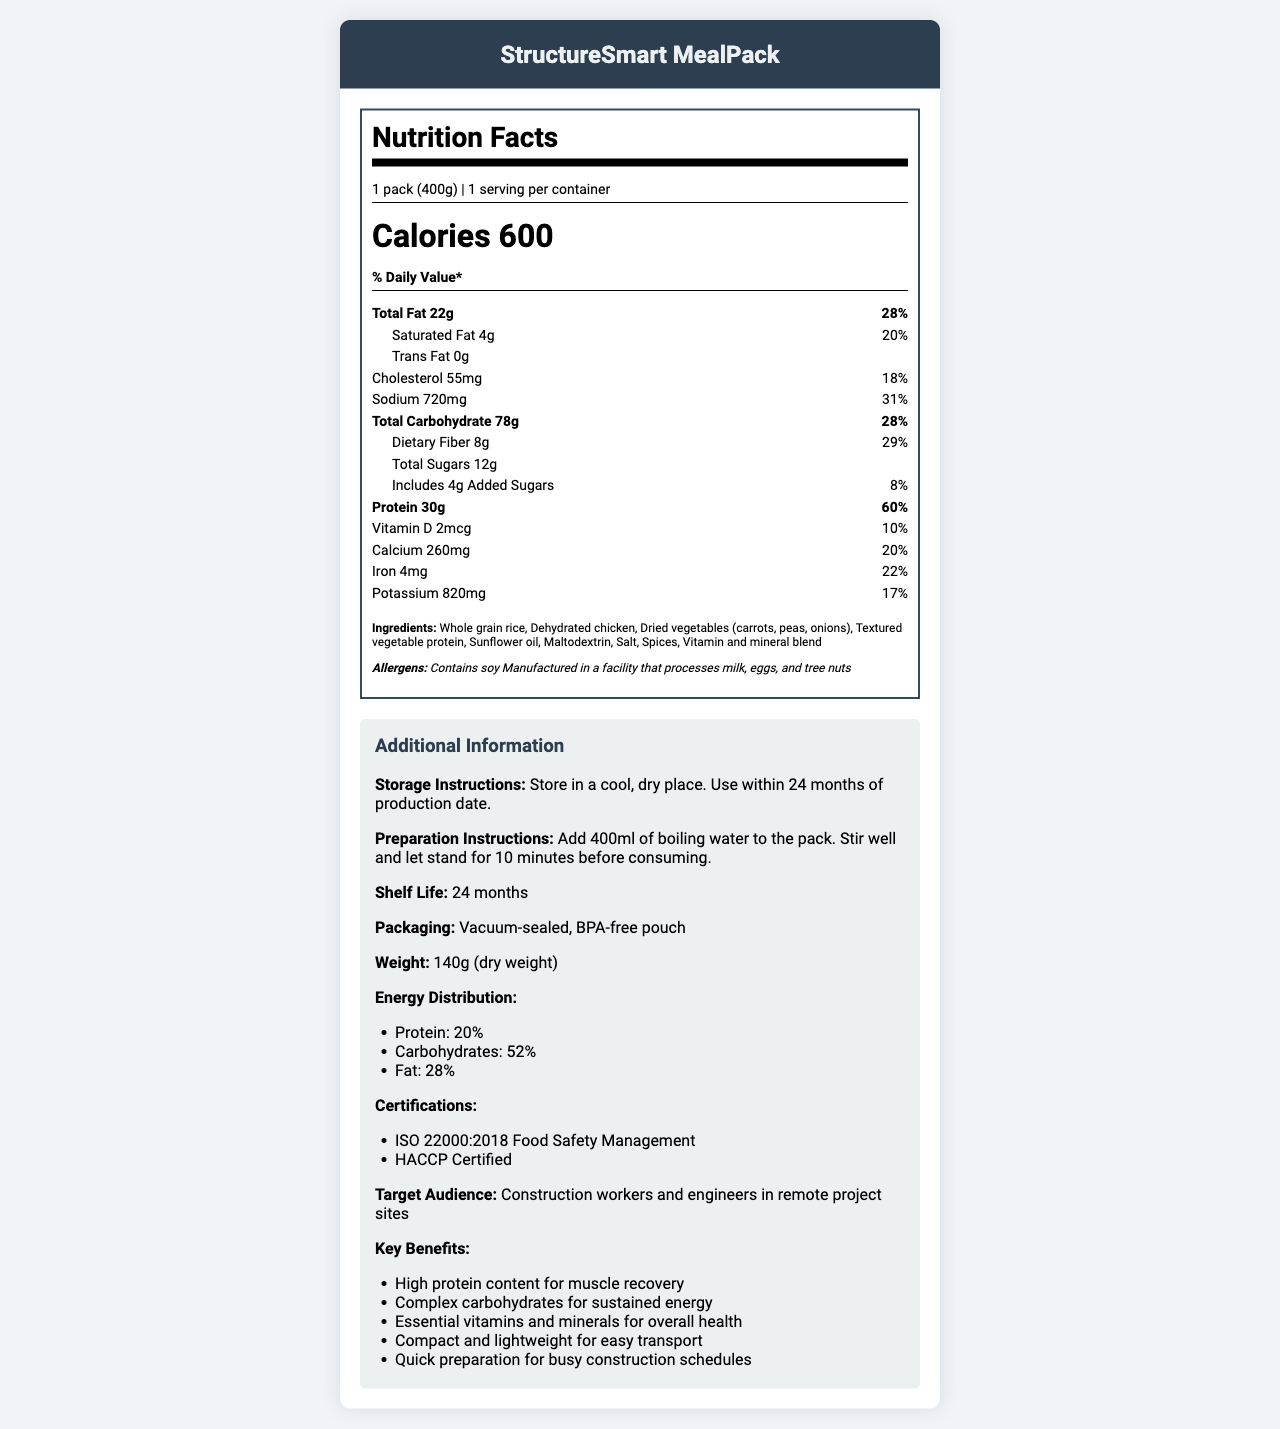what is the serving size for StructureSmart MealPack? The document clearly states that the serving size is "1 pack (400g)" under the serving information section.
Answer: 1 pack (400g) how many calories does one pack contain? The label indicates that there are 600 calories per serving, and since there is only one serving per container, one pack contains 600 calories.
Answer: 600 what is the total fat content for one serving, and what percentage of the daily value does it represent? The document lists the total fat as 22g, which is 28% of the daily value.
Answer: 22g, 28% how much dietary fiber is in one pack, and what's its daily value percentage? The document specifies that one pack contains 8g of dietary fiber, which is 29% of the daily value.
Answer: 8g, 29% what are the three primary ingredients of the StructureSmart MealPack? The primary ingredients listed first are "Whole grain rice", "Dehydrated chicken", and "Dried vegetables (carrots, peas, onions)".
Answer: Whole grain rice, Dehydrated chicken, Dried vegetables (carrots, peas, onions) what is the daily value percentage of protein provided by the StructureSmart MealPack? The document details that the protein content is 30g, which accounts for 60% of the daily value.
Answer: 60% what are the key benefits of the StructureSmart MealPack? The additional information section lists these key benefits.
Answer: High protein content for muscle recovery, Complex carbohydrates for sustained energy, Essential vitamins and minerals for overall health, Compact and lightweight for easy transport, Quick preparation for busy construction schedules does the StructureSmart MealPack contain any allergens? The document specifies that the product contains soy and is manufactured in a facility that processes milk, eggs, and tree nuts.
Answer: Yes what is the weight of StructureSmart MealPack in its dry form? Under additional information, the document states that the weight of the dry pack is 140g.
Answer: 140g who is the target audience for the StructureSmart MealPack? The document's additional information specifies that the target audience includes "Construction workers and engineers in remote project sites".
Answer: Construction workers and engineers in remote project sites what is the main idea of the StructureSmart MealPack document? The document is a comprehensive overview showcasing the nutritional breakdown, key ingredients, preparation instructions, benefits, and intended users of the StructureSmart MealPack.
Answer: The document provides detailed nutritional information, ingredients, storage and preparation instructions, and additional benefits, certifications, and target audience information for the StructureSmart MealPack, a high-protein, nutrient-rich, compact meal designed for construction workers and engineers at remote project sites. how long is the shelf life of the StructureSmart MealPack? Under additional information, the shelf life is listed as 24 months.
Answer: 24 months how much sodium does the StructureSmart MealPack contain, and what percentage of the daily value does it represent? The nutrition facts section shows that the sodium content is 720mg, which is 31% of the daily value.
Answer: 720mg, 31% can you determine the production date of the StructureSmart MealPack from the document? The document specifies a shelf life of 24 months but does not provide the production date required to determine this.
Answer: Not enough information what are the preparation instructions for the StructureSmart MealPack? The document details that 400ml of boiling water should be added, then stir and let it stand for 10 minutes before consumption.
Answer: Add 400ml of boiling water to the pack. Stir well and let stand for 10 minutes before consuming. 